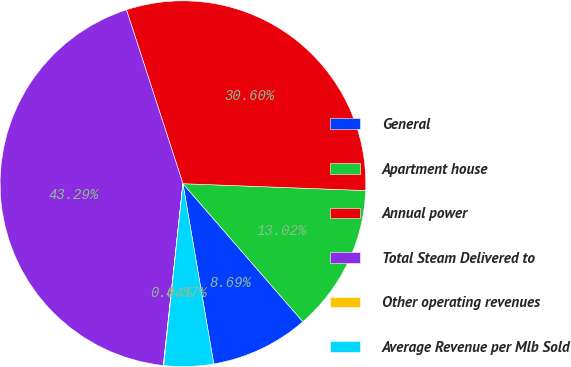Convert chart. <chart><loc_0><loc_0><loc_500><loc_500><pie_chart><fcel>General<fcel>Apartment house<fcel>Annual power<fcel>Total Steam Delivered to<fcel>Other operating revenues<fcel>Average Revenue per Mlb Sold<nl><fcel>8.69%<fcel>13.02%<fcel>30.6%<fcel>43.29%<fcel>0.04%<fcel>4.37%<nl></chart> 